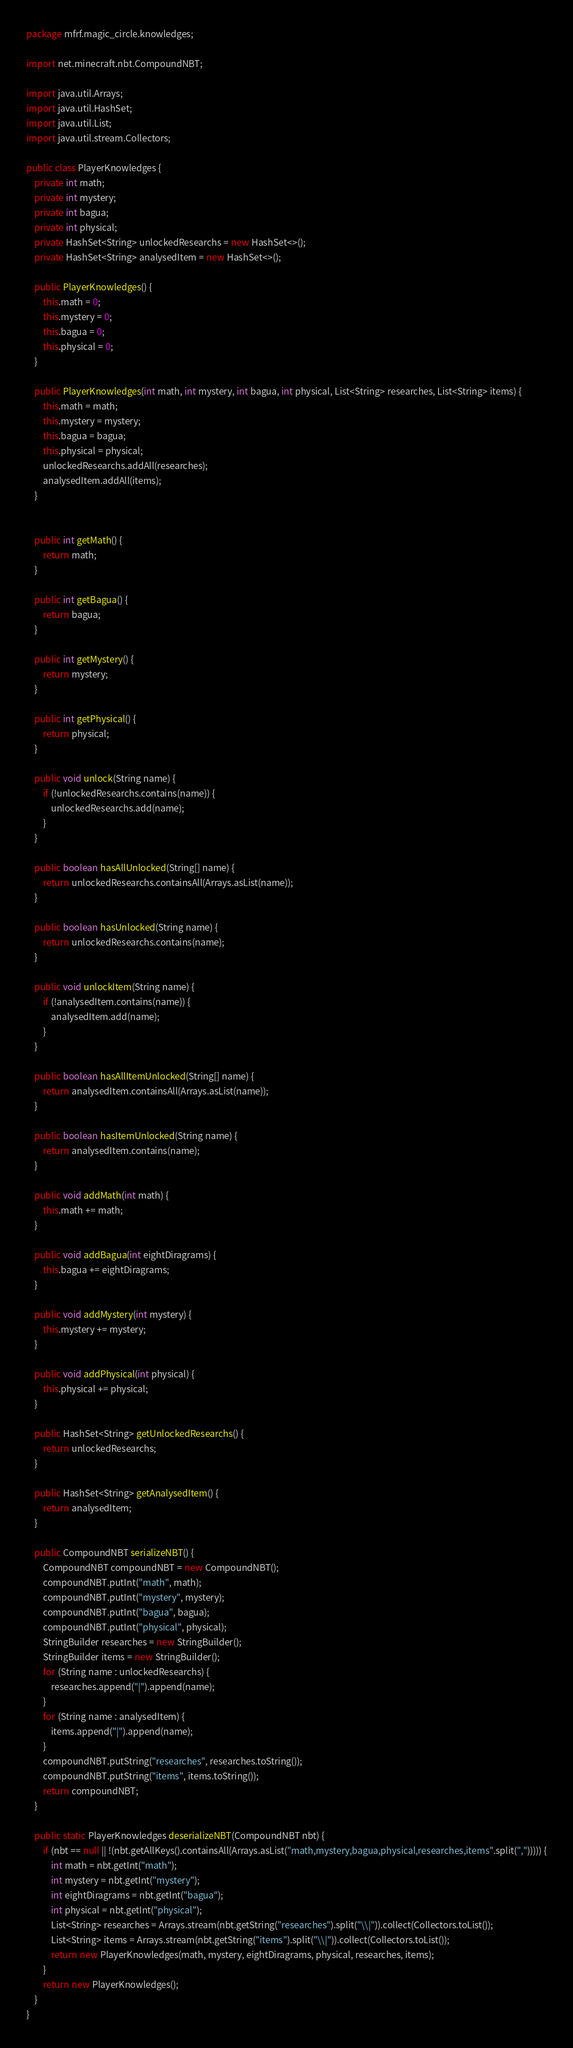Convert code to text. <code><loc_0><loc_0><loc_500><loc_500><_Java_>package mfrf.magic_circle.knowledges;

import net.minecraft.nbt.CompoundNBT;

import java.util.Arrays;
import java.util.HashSet;
import java.util.List;
import java.util.stream.Collectors;

public class PlayerKnowledges {
    private int math;
    private int mystery;
    private int bagua;
    private int physical;
    private HashSet<String> unlockedResearchs = new HashSet<>();
    private HashSet<String> analysedItem = new HashSet<>();

    public PlayerKnowledges() {
        this.math = 0;
        this.mystery = 0;
        this.bagua = 0;
        this.physical = 0;
    }

    public PlayerKnowledges(int math, int mystery, int bagua, int physical, List<String> researches, List<String> items) {
        this.math = math;
        this.mystery = mystery;
        this.bagua = bagua;
        this.physical = physical;
        unlockedResearchs.addAll(researches);
        analysedItem.addAll(items);
    }


    public int getMath() {
        return math;
    }

    public int getBagua() {
        return bagua;
    }

    public int getMystery() {
        return mystery;
    }

    public int getPhysical() {
        return physical;
    }

    public void unlock(String name) {
        if (!unlockedResearchs.contains(name)) {
            unlockedResearchs.add(name);
        }
    }

    public boolean hasAllUnlocked(String[] name) {
        return unlockedResearchs.containsAll(Arrays.asList(name));
    }

    public boolean hasUnlocked(String name) {
        return unlockedResearchs.contains(name);
    }

    public void unlockItem(String name) {
        if (!analysedItem.contains(name)) {
            analysedItem.add(name);
        }
    }

    public boolean hasAllItemUnlocked(String[] name) {
        return analysedItem.containsAll(Arrays.asList(name));
    }

    public boolean hasItemUnlocked(String name) {
        return analysedItem.contains(name);
    }

    public void addMath(int math) {
        this.math += math;
    }

    public void addBagua(int eightDiragrams) {
        this.bagua += eightDiragrams;
    }

    public void addMystery(int mystery) {
        this.mystery += mystery;
    }

    public void addPhysical(int physical) {
        this.physical += physical;
    }

    public HashSet<String> getUnlockedResearchs() {
        return unlockedResearchs;
    }

    public HashSet<String> getAnalysedItem() {
        return analysedItem;
    }

    public CompoundNBT serializeNBT() {
        CompoundNBT compoundNBT = new CompoundNBT();
        compoundNBT.putInt("math", math);
        compoundNBT.putInt("mystery", mystery);
        compoundNBT.putInt("bagua", bagua);
        compoundNBT.putInt("physical", physical);
        StringBuilder researches = new StringBuilder();
        StringBuilder items = new StringBuilder();
        for (String name : unlockedResearchs) {
            researches.append("|").append(name);
        }
        for (String name : analysedItem) {
            items.append("|").append(name);
        }
        compoundNBT.putString("researches", researches.toString());
        compoundNBT.putString("items", items.toString());
        return compoundNBT;
    }

    public static PlayerKnowledges deserializeNBT(CompoundNBT nbt) {
        if (nbt == null || !(nbt.getAllKeys().containsAll(Arrays.asList("math,mystery,bagua,physical,researches,items".split(","))))) {
            int math = nbt.getInt("math");
            int mystery = nbt.getInt("mystery");
            int eightDiragrams = nbt.getInt("bagua");
            int physical = nbt.getInt("physical");
            List<String> researches = Arrays.stream(nbt.getString("researches").split("\\|")).collect(Collectors.toList());
            List<String> items = Arrays.stream(nbt.getString("items").split("\\|")).collect(Collectors.toList());
            return new PlayerKnowledges(math, mystery, eightDiragrams, physical, researches, items);
        }
        return new PlayerKnowledges();
    }
}
</code> 